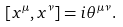<formula> <loc_0><loc_0><loc_500><loc_500>\left [ x ^ { \mu } , x ^ { \nu } \right ] = i \theta ^ { \mu \nu } .</formula> 